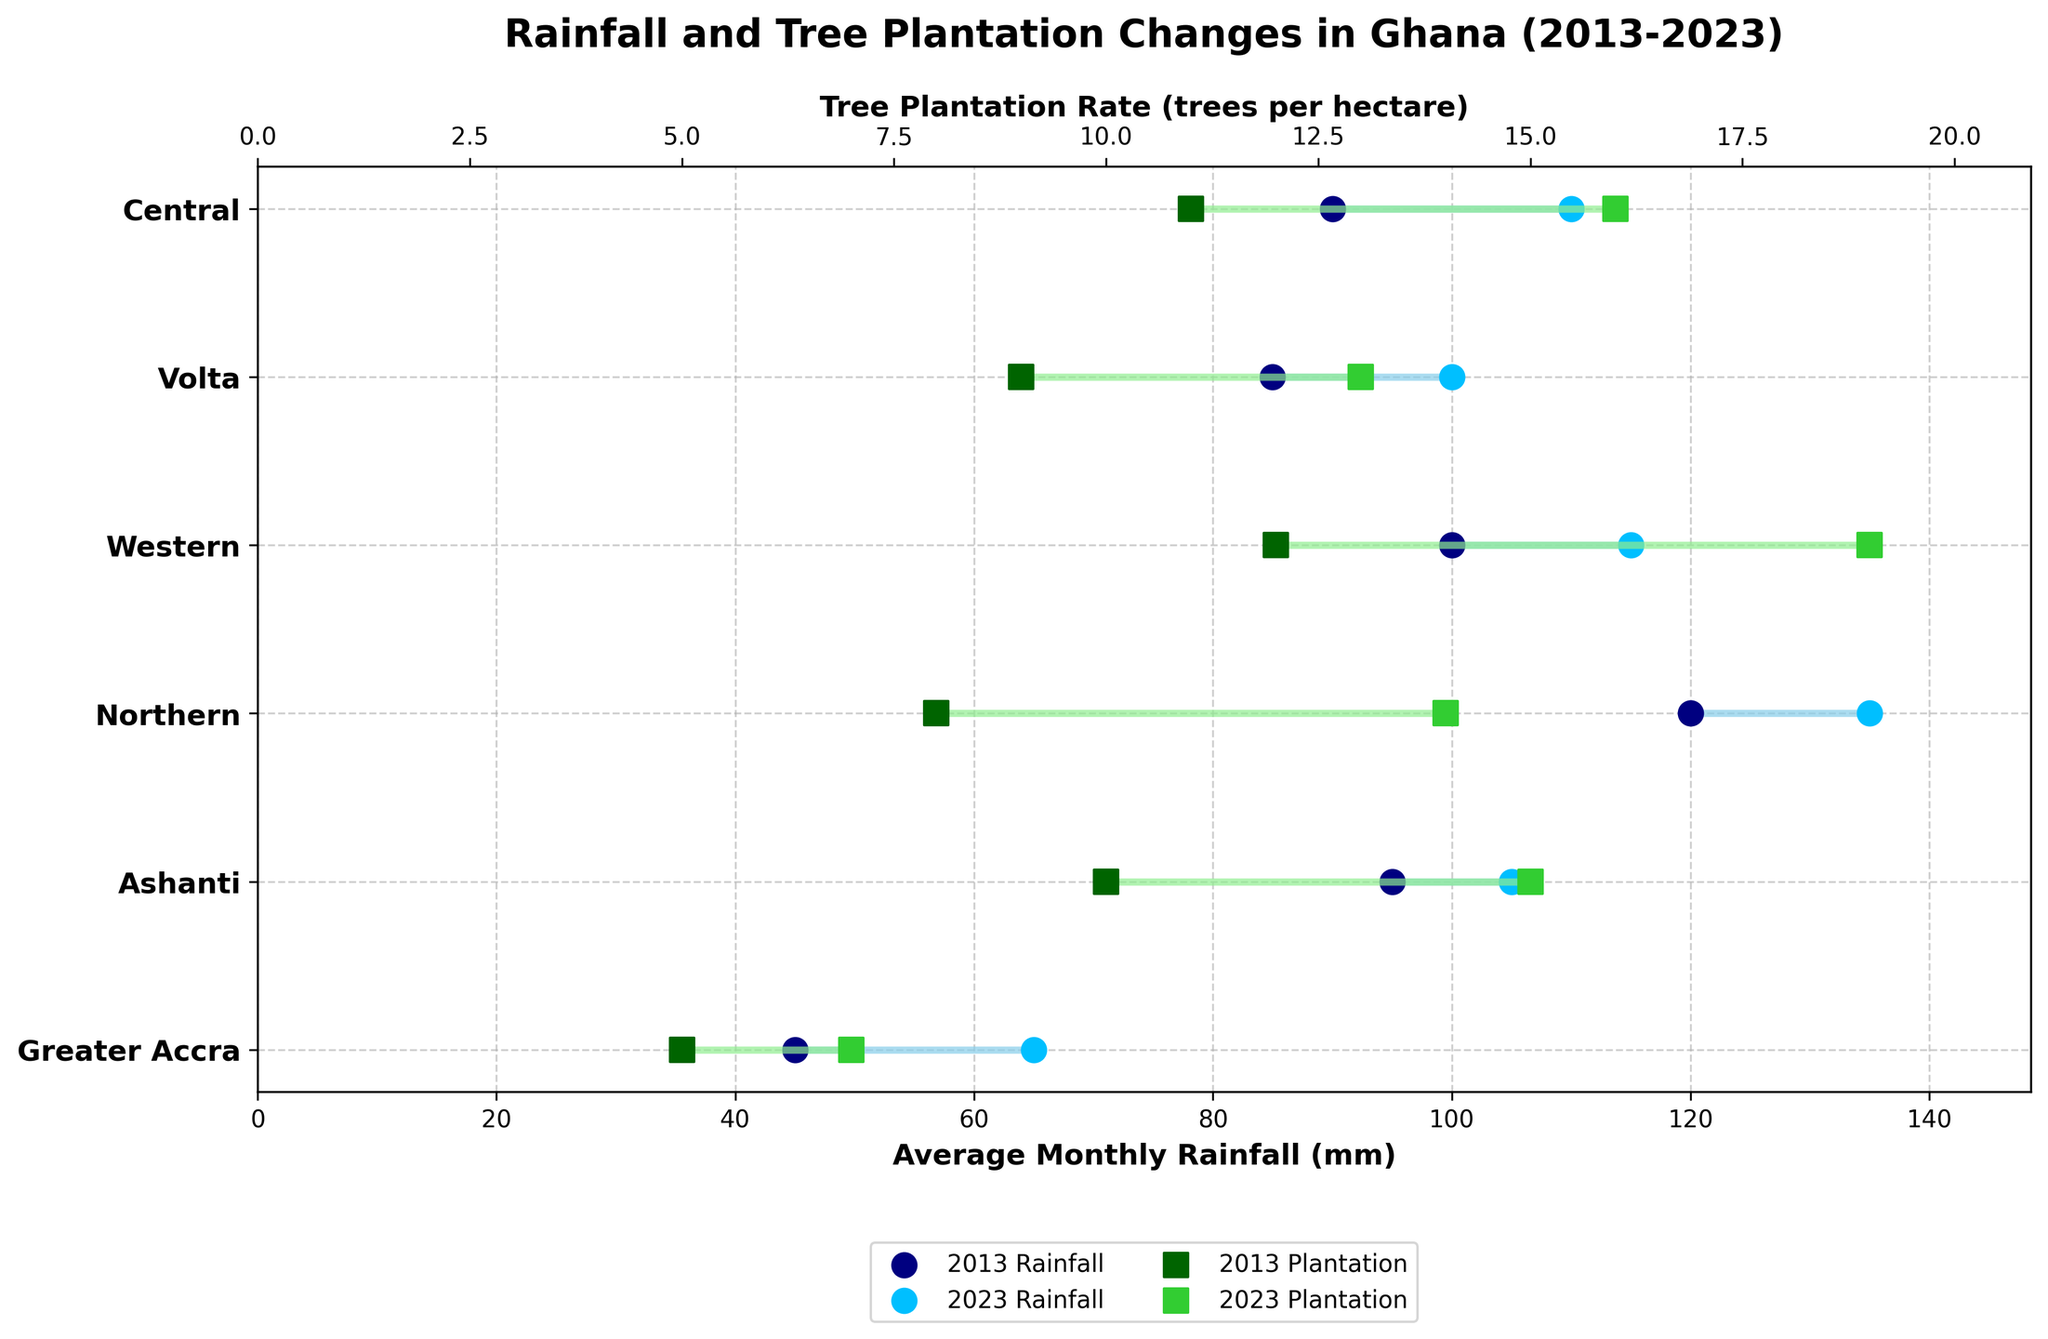How much did the average monthly rainfall increase in Greater Accra from 2013 to 2023? The average monthly rainfall in Greater Accra in 2013 is 45 mm and in 2023 it is 65 mm. The increase is 65 mm - 45 mm = 20 mm.
Answer: 20 mm Which region experienced the largest increase in tree plantation rate from 2013 to 2023? By comparing the changes, we see that Western increased from 12 trees per hectare to 19 trees per hectare, the highest increase of 7 trees per hectare.
Answer: Western How does the tree plantation rate in Ashanti in 2023 compare to the plantation rate in Northern in 2013? The tree plantation rate in Ashanti in 2023 is 15 trees per hectare and in Northern in 2013 it is 8 trees per hectare. Since 15 > 8, Ashanti in 2023 has a higher rate.
Answer: Ashanti in 2023 is higher What was the average tree plantation rate for all regions in 2013? Sum tree plantation rates in 2013: 5 + 10 + 8 + 12 + 9 + 11 = 55. The number of regions is 6. The average is 55/6 = 9.17 (rounded to 2 decimal places).
Answer: 9.17 trees per hectare Which region saw the smallest change in average monthly rainfall over the decade? Calculating differences, Greater Accra increased by 20 mm, Ashanti by 10 mm, Northern by 15 mm, Western by 15 mm, Volta by 15 mm, and Central by 20 mm. Ashanti has the smallest change with 10 mm.
Answer: Ashanti Is there a region where the increase in tree plantation rate and rainfall is equal over the last decade? By comparing the increase, we see that none of the regions has equal increases in both rainfall and plantation rate.
Answer: No What was the combined increase in average monthly rainfall for Western and Central regions over the decade? Western increased from 100 mm to 115 mm (15 mm increase), and Central increased from 90 mm to 110 mm (20 mm increase). Combined increase: 15 mm + 20 mm = 35 mm.
Answer: 35 mm In which region did both average monthly rainfall and tree plantation rate both increase by at least 15 units over the decade? Western's rainfall increased from 100 mm to 115 mm, and plantation from 12 to 19. Volta's increase is 85 to 100 (rainfall) and 9 to 13 (plantation) doesn't meet criteria. Only Western meets the criteria.
Answer: Western How did the plantation rate in Central in 2023 compare to the plantation rate in Ashanti in 2013? The plantation rate in Central in 2023 is 16 trees per hectare and in Ashanti in 2013 is 10 trees per hectare. Since 16 > 10, Central in 2023 is higher.
Answer: Central in 2023 is higher Which year had higher average monthly rainfall for Northern region? From the plot, in the Northern region, 2023 had 135 mm and 2013 had 120 mm. Since 135 > 120, 2023 had higher rainfall.
Answer: 2023 